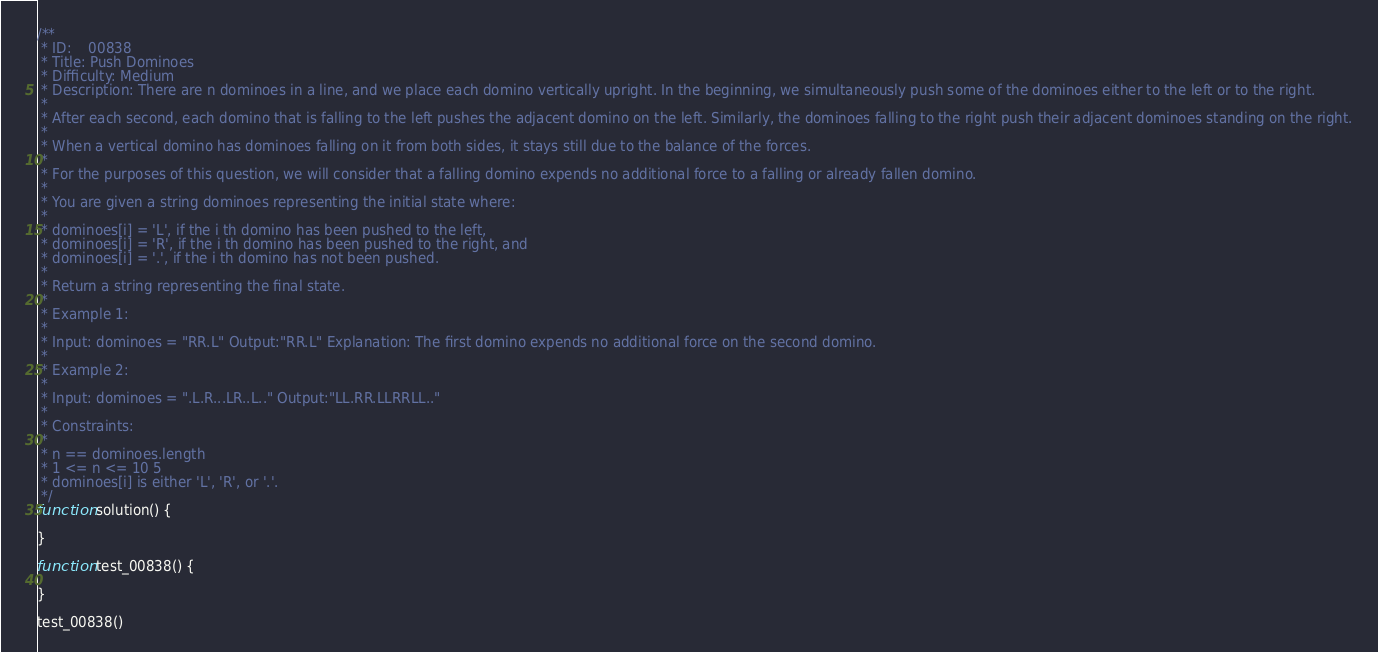<code> <loc_0><loc_0><loc_500><loc_500><_TypeScript_>/**
 * ID:    00838
 * Title: Push Dominoes
 * Difficulty: Medium
 * Description: There are n dominoes in a line, and we place each domino vertically upright. In the beginning, we simultaneously push some of the dominoes either to the left or to the right.
 * 
 * After each second, each domino that is falling to the left pushes the adjacent domino on the left. Similarly, the dominoes falling to the right push their adjacent dominoes standing on the right.
 * 
 * When a vertical domino has dominoes falling on it from both sides, it stays still due to the balance of the forces.
 * 
 * For the purposes of this question, we will consider that a falling domino expends no additional force to a falling or already fallen domino.
 * 
 * You are given a string dominoes representing the initial state where:
 * 
 * dominoes[i] = 'L', if the i th domino has been pushed to the left,
 * dominoes[i] = 'R', if the i th domino has been pushed to the right, and
 * dominoes[i] = '.', if the i th domino has not been pushed.
 * 
 * Return a string representing the final state.
 * 
 * Example 1:
 * 
 * Input: dominoes = "RR.L" Output:"RR.L" Explanation: The first domino expends no additional force on the second domino.
 * 
 * Example 2:
 * 
 * Input: dominoes = ".L.R...LR..L.." Output:"LL.RR.LLRRLL.."
 * 
 * Constraints:
 * 
 * n == dominoes.length
 * 1 <= n <= 10 5
 * dominoes[i] is either 'L', 'R', or '.'.
 */
function solution() {
  
}

function test_00838() {
  
}

test_00838()
</code> 